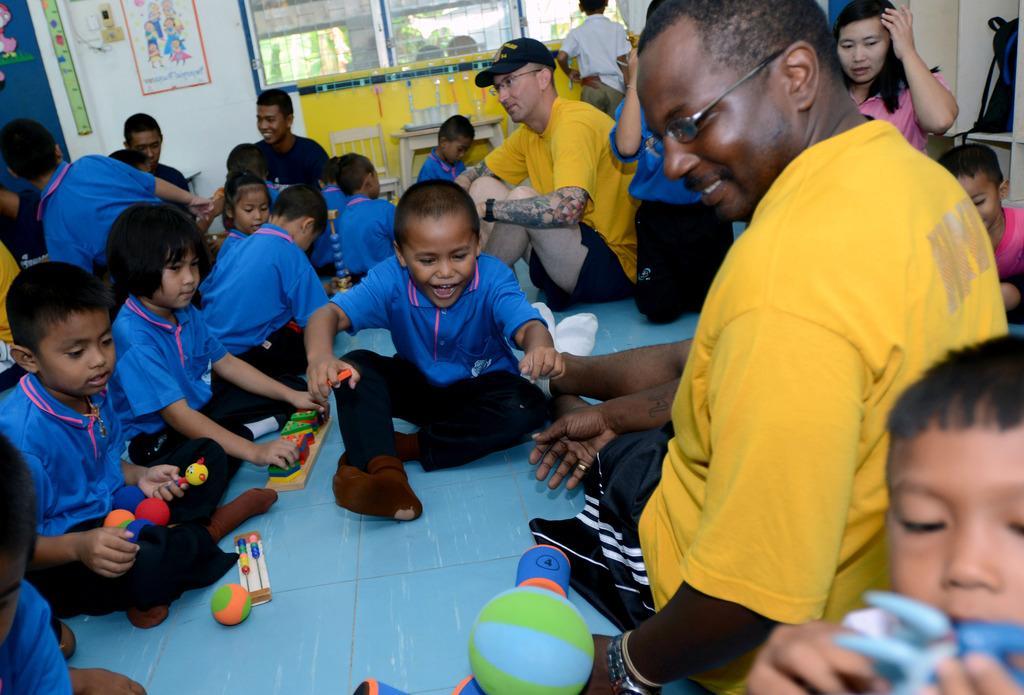Describe this image in one or two sentences. In this image I can see few people are sitting and they are wearing blue, black, yellow, white and pink color dresses. I can see few toys, wall, table, chair, windows and colorful boards. 